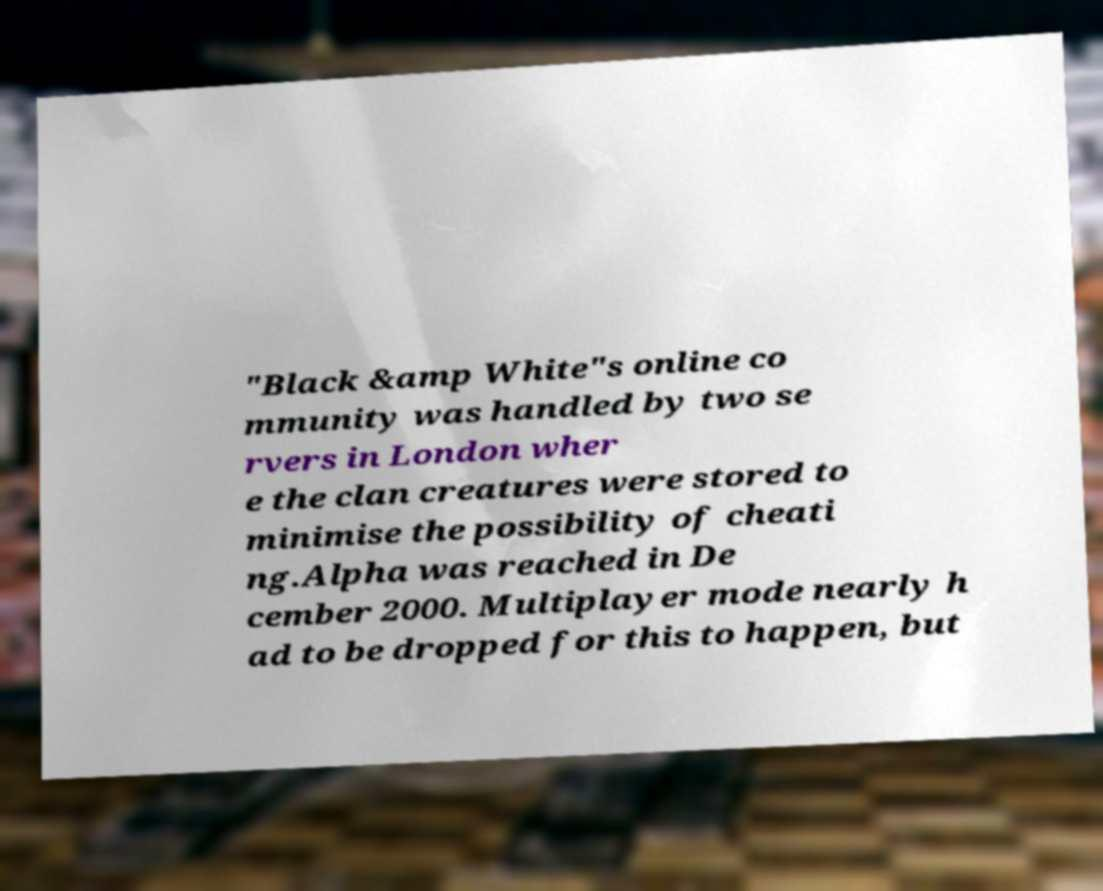I need the written content from this picture converted into text. Can you do that? "Black &amp White"s online co mmunity was handled by two se rvers in London wher e the clan creatures were stored to minimise the possibility of cheati ng.Alpha was reached in De cember 2000. Multiplayer mode nearly h ad to be dropped for this to happen, but 